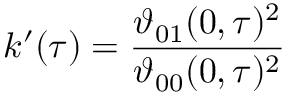Convert formula to latex. <formula><loc_0><loc_0><loc_500><loc_500>k ^ { \prime } ( \tau ) = { \frac { \vartheta _ { 0 1 } ( 0 , \tau ) ^ { 2 } } { \vartheta _ { 0 0 } ( 0 , \tau ) ^ { 2 } } }</formula> 